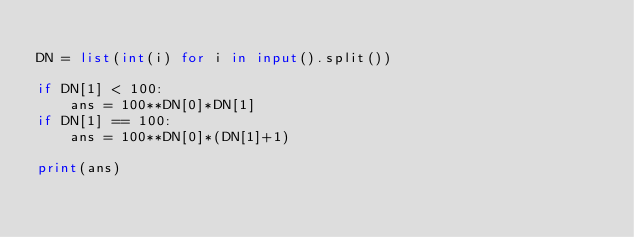Convert code to text. <code><loc_0><loc_0><loc_500><loc_500><_Python_>
DN = list(int(i) for i in input().split())

if DN[1] < 100:
    ans = 100**DN[0]*DN[1]
if DN[1] == 100:
    ans = 100**DN[0]*(DN[1]+1)

print(ans)</code> 